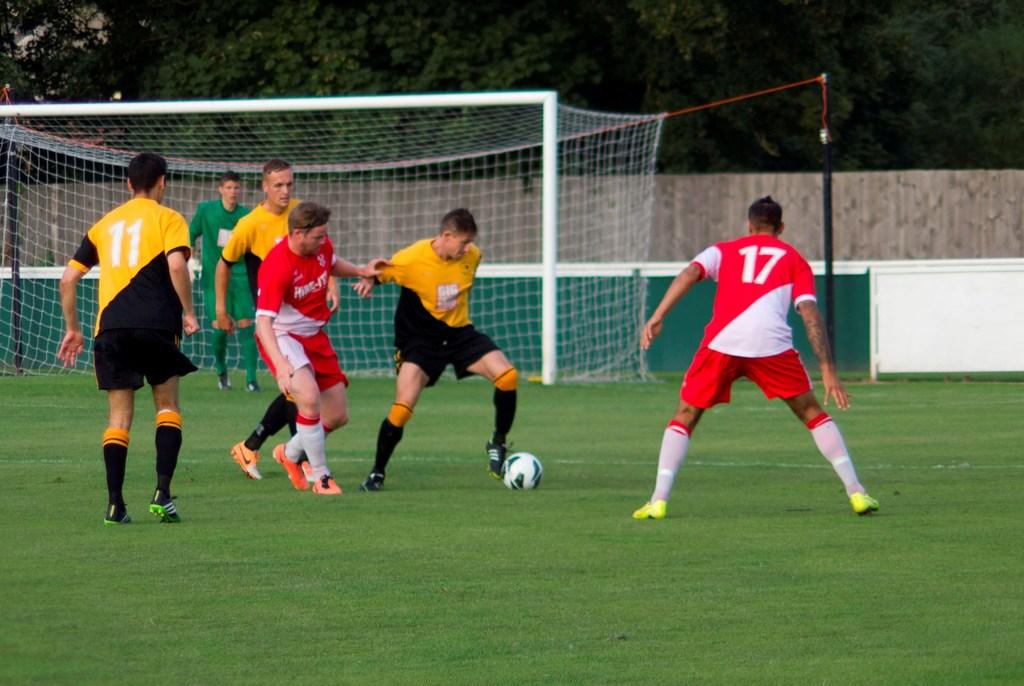What is the player number in the red/white jersey?
Your answer should be very brief. 17. What color is the jersey number 17?
Ensure brevity in your answer.  Red. 